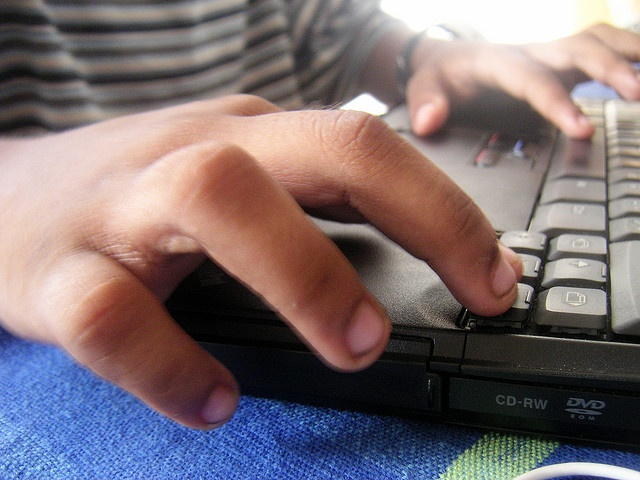Describe the objects in this image and their specific colors. I can see people in black, gray, lightgray, brown, and maroon tones and keyboard in black, darkgray, gray, and lightgray tones in this image. 